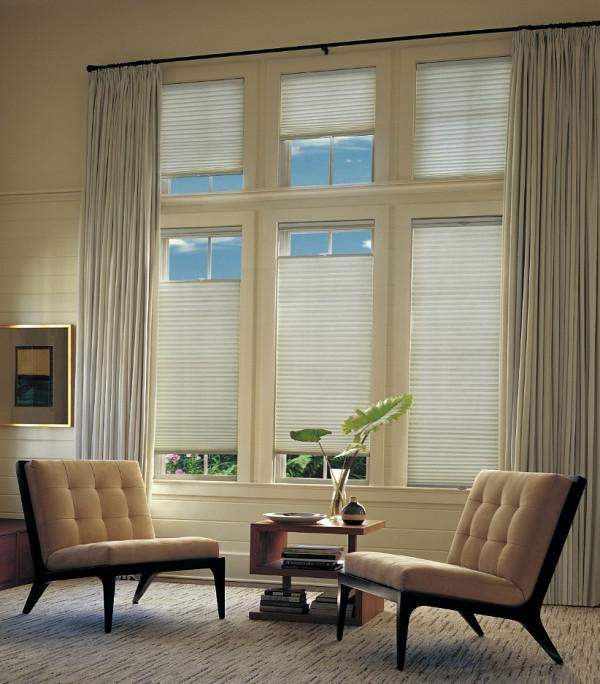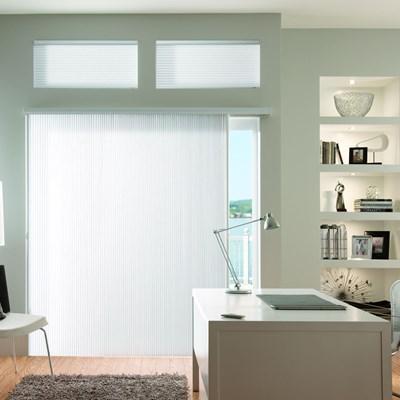The first image is the image on the left, the second image is the image on the right. For the images displayed, is the sentence "There are the same number of windows in both images." factually correct? Answer yes or no. No. 